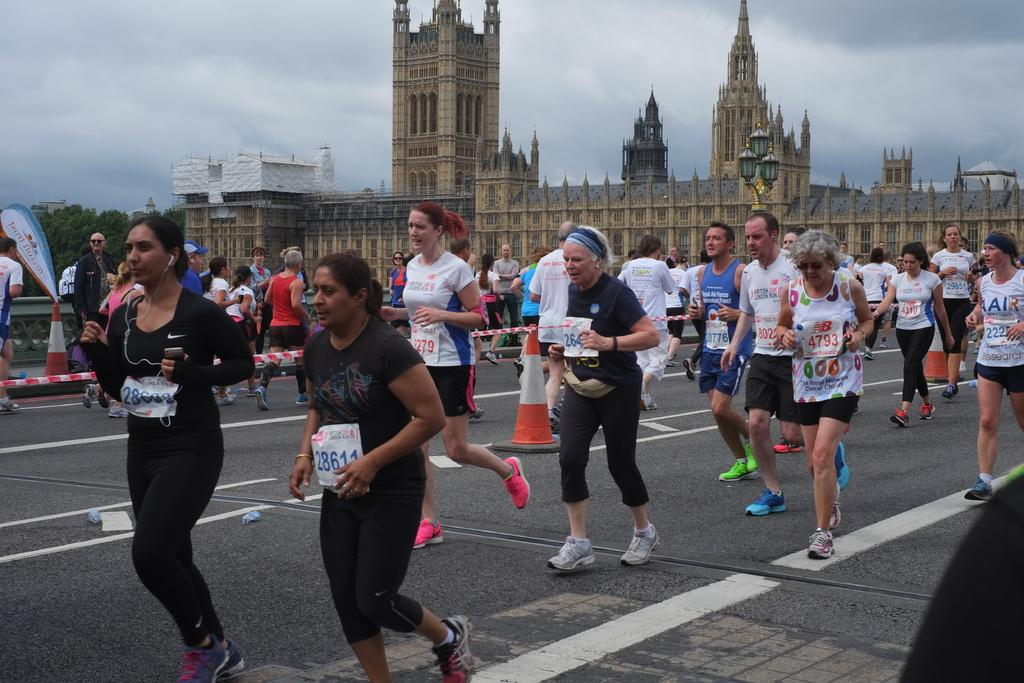What are the persons in the image doing? The persons in the image are running on the road. What objects are present on the road in the image? Traffic cones are present in the image. What can be seen in the background of the image? There is a building, street lights, trees, and the sky visible in the background of the image. What is the condition of the sky in the image? Clouds are present in the sky in the image. What type of bread can be seen being ploughed in the image? There is no bread or ploughing activity present in the image. 